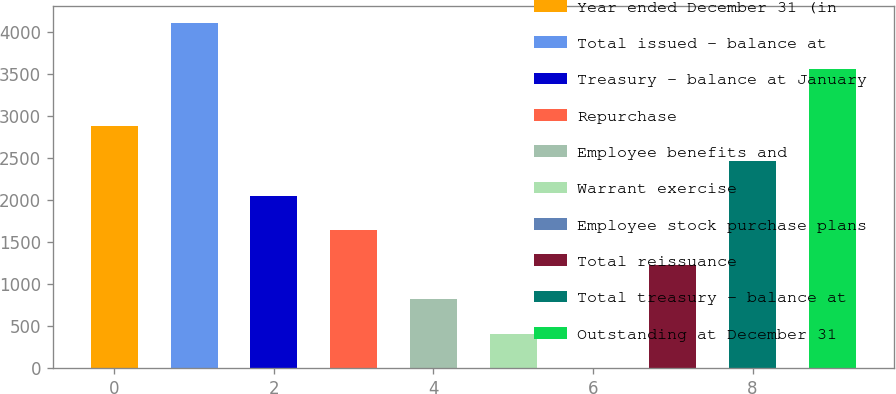<chart> <loc_0><loc_0><loc_500><loc_500><bar_chart><fcel>Year ended December 31 (in<fcel>Total issued - balance at<fcel>Treasury - balance at January<fcel>Repurchase<fcel>Employee benefits and<fcel>Warrant exercise<fcel>Employee stock purchase plans<fcel>Total reissuance<fcel>Total treasury - balance at<fcel>Outstanding at December 31<nl><fcel>2873.73<fcel>4104.9<fcel>2052.95<fcel>1642.56<fcel>821.78<fcel>411.39<fcel>1<fcel>1232.17<fcel>2463.34<fcel>3561.2<nl></chart> 